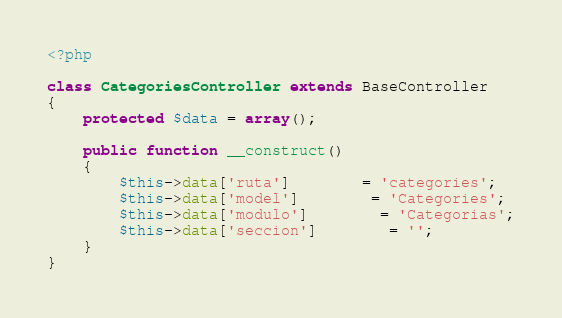<code> <loc_0><loc_0><loc_500><loc_500><_PHP_><?php

class CategoriesController extends BaseController
{
	protected $data = array();

	public function __construct()
	{
		$this->data['ruta'] 		= 'categories';
		$this->data['model'] 		= 'Categories';
		$this->data['modulo'] 		= 'Categorias';
		$this->data['seccion']		= '';
	}
}</code> 